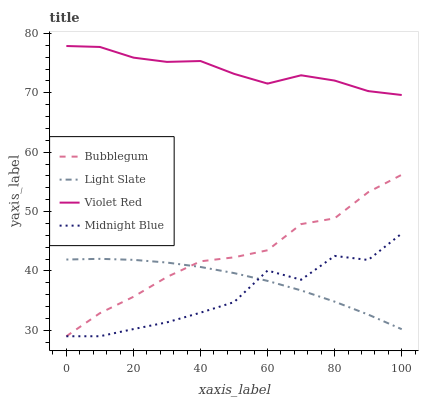Does Midnight Blue have the minimum area under the curve?
Answer yes or no. Yes. Does Violet Red have the maximum area under the curve?
Answer yes or no. Yes. Does Violet Red have the minimum area under the curve?
Answer yes or no. No. Does Midnight Blue have the maximum area under the curve?
Answer yes or no. No. Is Light Slate the smoothest?
Answer yes or no. Yes. Is Midnight Blue the roughest?
Answer yes or no. Yes. Is Violet Red the smoothest?
Answer yes or no. No. Is Violet Red the roughest?
Answer yes or no. No. Does Midnight Blue have the lowest value?
Answer yes or no. Yes. Does Violet Red have the lowest value?
Answer yes or no. No. Does Violet Red have the highest value?
Answer yes or no. Yes. Does Midnight Blue have the highest value?
Answer yes or no. No. Is Light Slate less than Violet Red?
Answer yes or no. Yes. Is Violet Red greater than Bubblegum?
Answer yes or no. Yes. Does Light Slate intersect Midnight Blue?
Answer yes or no. Yes. Is Light Slate less than Midnight Blue?
Answer yes or no. No. Is Light Slate greater than Midnight Blue?
Answer yes or no. No. Does Light Slate intersect Violet Red?
Answer yes or no. No. 